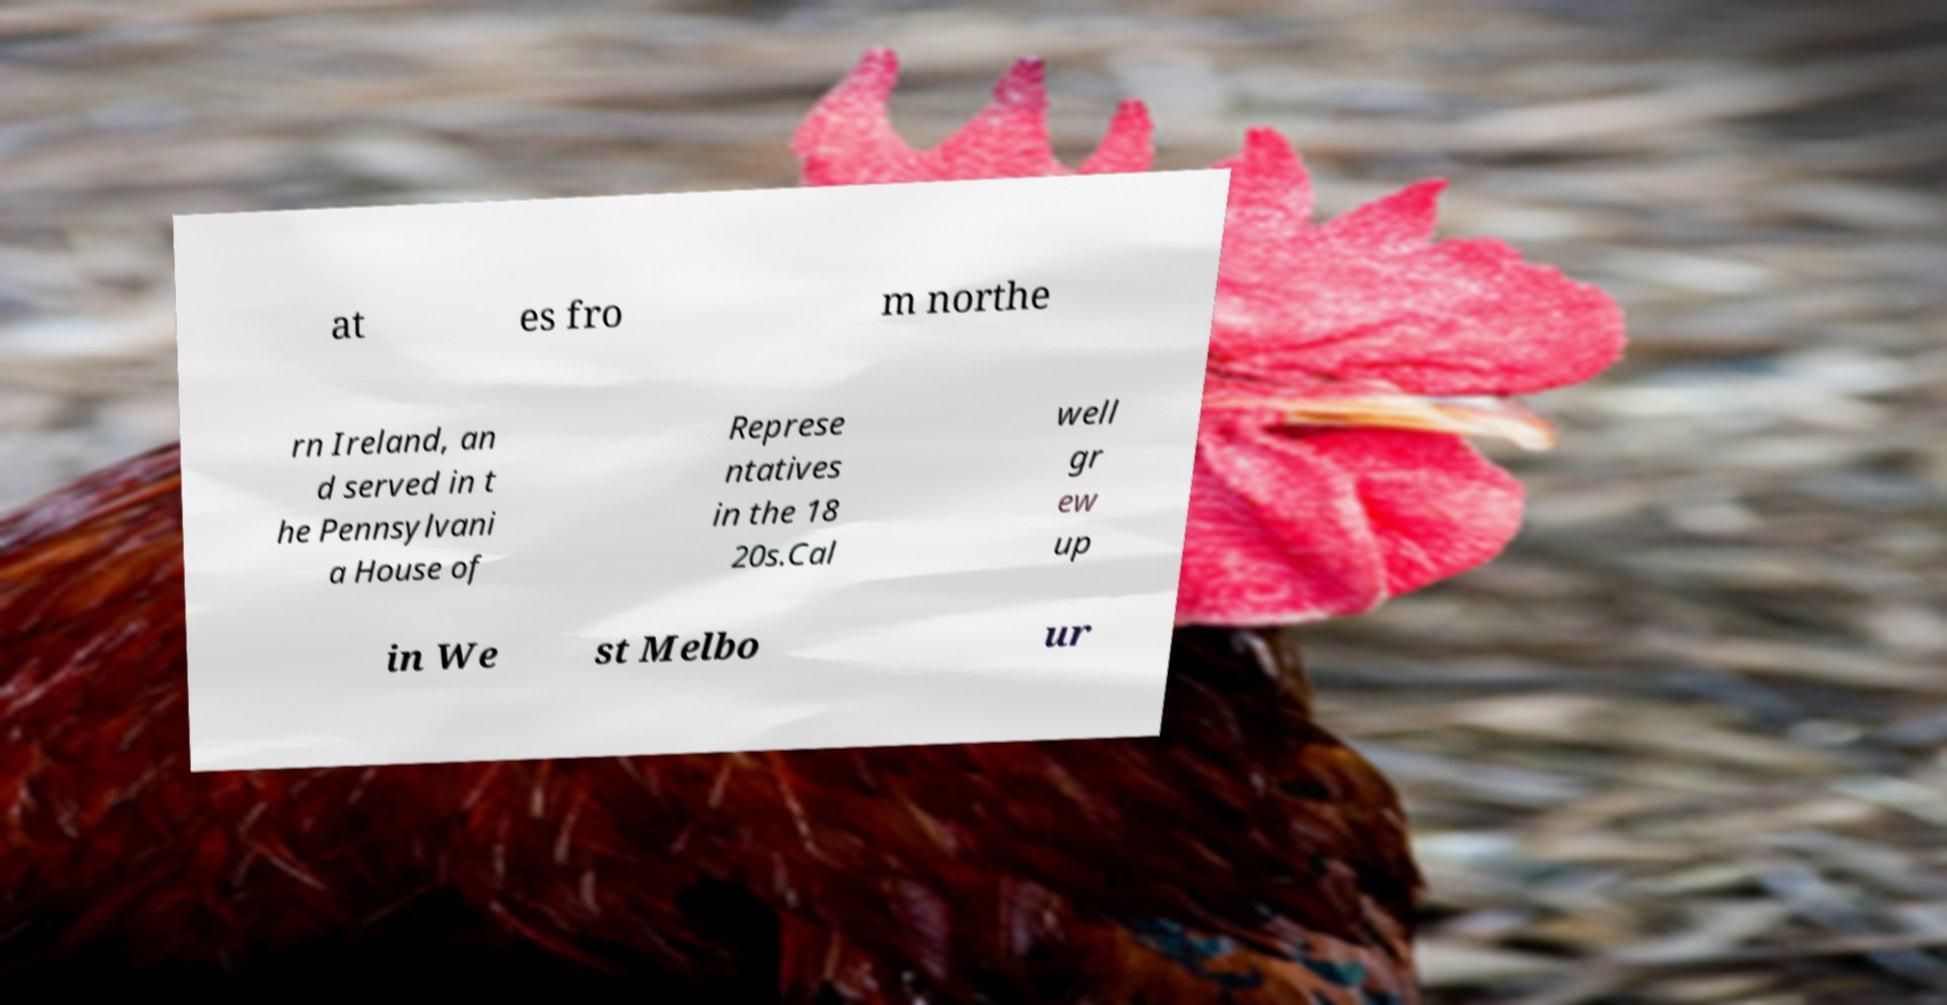Can you accurately transcribe the text from the provided image for me? at es fro m northe rn Ireland, an d served in t he Pennsylvani a House of Represe ntatives in the 18 20s.Cal well gr ew up in We st Melbo ur 